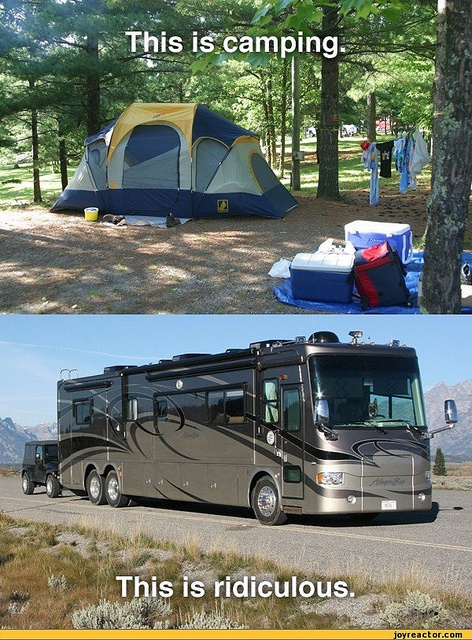Describe the objects in this image and their specific colors. I can see bus in blue, black, gray, and darkgray tones, backpack in blue, black, maroon, navy, and salmon tones, and car in blue, black, gray, and darkgray tones in this image. 